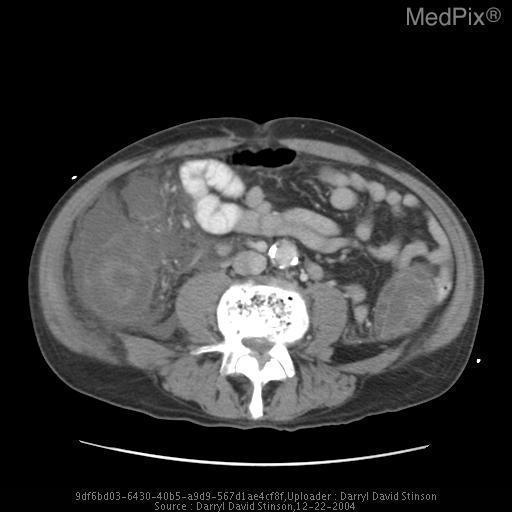Is iv contrast used?
Keep it brief. Yes. In which vessel is calcification present?
Concise answer only. Aorta. The calcification is located in what vessel?
Answer briefly. Aorta. 